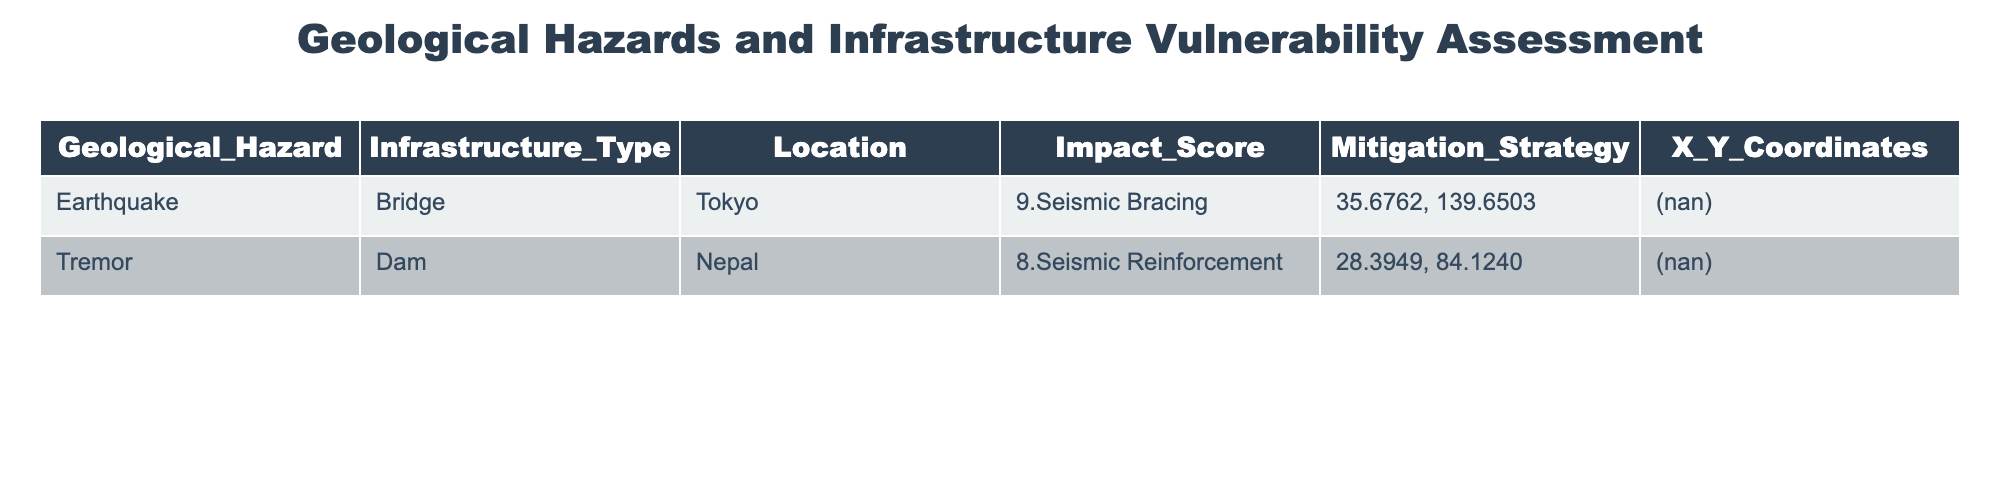What is the impact score for the bridge in Tokyo? The table states the impact score for the bridge in Tokyo as 9.
Answer: 9 What mitigation strategy is listed for the dam in Nepal? According to the table, the mitigation strategy for the dam in Nepal is seismic reinforcement.
Answer: Seismic Reinforcement Is there an earthquake hazard associated with any infrastructure type in the table? Looking at the table, there is an earthquake hazard listed for the bridge in Tokyo. Therefore, the answer is yes.
Answer: Yes What is the average impact score for the geological hazards listed in the table? The two impact scores are 9 and 8. Adding them gives 17. Dividing by the number of hazards (2), the average is 17/2 = 8.5.
Answer: 8.5 Are there more than one infrastructure types listed in the table? The table contains two infrastructure types: a bridge and a dam. Therefore, the answer is yes.
Answer: Yes What is the total number of geological hazards represented in the table? The table lists two geological hazards: earthquake and tremor. Thus, the total is 2.
Answer: 2 Which location has the highest impact score for infrastructure vulnerability? Examining the impact scores, Tokyo has the highest impact score of 9 compared to Nepal's 8. Therefore, Tokyo is the location with the highest score.
Answer: Tokyo If we consider only the infrastructure types, what percentage of these types are bridges? There are two infrastructure types: one bridge and one dam. Thus, the percentage of bridges is (1/2) * 100 = 50%.
Answer: 50% Is the seismic bracing mentioned in relation to the dam in the table? The seismic bracing is not mentioned for the dam; it is specifically listed for the bridge in Tokyo. Therefore, the answer is no.
Answer: No 